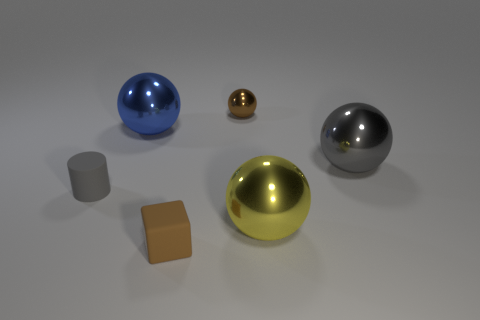Add 2 big blue objects. How many objects exist? 8 Subtract all big blue balls. How many balls are left? 3 Subtract all spheres. How many objects are left? 2 Subtract all gray balls. How many balls are left? 3 Subtract 1 spheres. How many spheres are left? 3 Add 1 brown matte objects. How many brown matte objects are left? 2 Add 4 tiny rubber cubes. How many tiny rubber cubes exist? 5 Subtract 0 cyan cylinders. How many objects are left? 6 Subtract all gray cubes. Subtract all red cylinders. How many cubes are left? 1 Subtract all green cylinders. How many yellow spheres are left? 1 